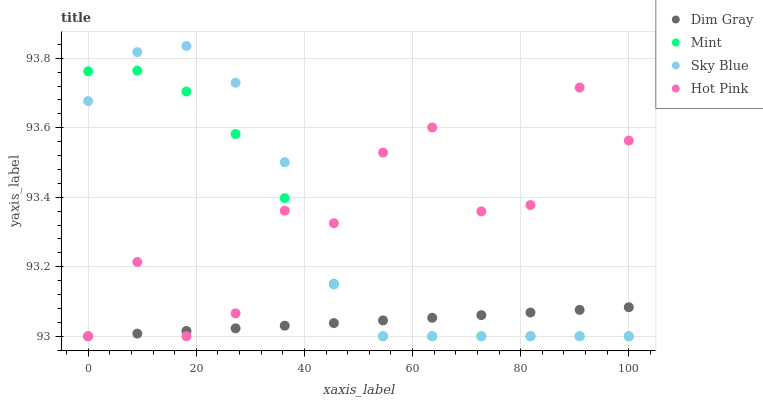Does Dim Gray have the minimum area under the curve?
Answer yes or no. Yes. Does Hot Pink have the maximum area under the curve?
Answer yes or no. Yes. Does Mint have the minimum area under the curve?
Answer yes or no. No. Does Mint have the maximum area under the curve?
Answer yes or no. No. Is Dim Gray the smoothest?
Answer yes or no. Yes. Is Hot Pink the roughest?
Answer yes or no. Yes. Is Mint the smoothest?
Answer yes or no. No. Is Mint the roughest?
Answer yes or no. No. Does Sky Blue have the lowest value?
Answer yes or no. Yes. Does Sky Blue have the highest value?
Answer yes or no. Yes. Does Mint have the highest value?
Answer yes or no. No. Does Hot Pink intersect Dim Gray?
Answer yes or no. Yes. Is Hot Pink less than Dim Gray?
Answer yes or no. No. Is Hot Pink greater than Dim Gray?
Answer yes or no. No. 